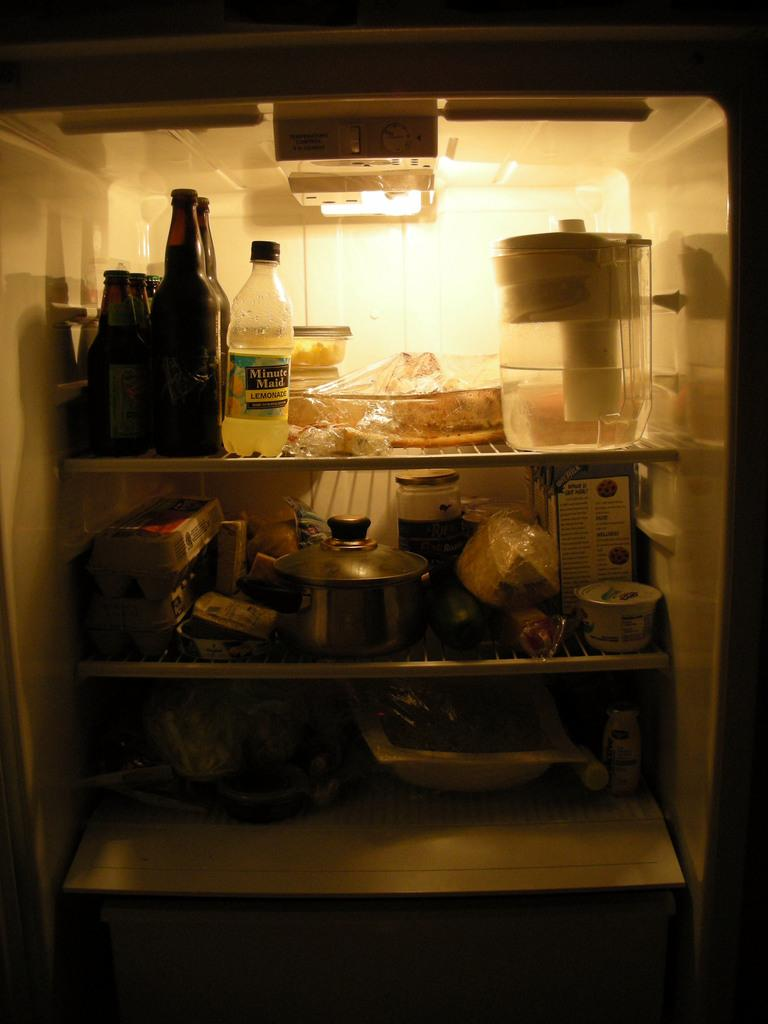Provide a one-sentence caption for the provided image. A refrigerator is stocked with food and products, including Minute Maid lemonade. 